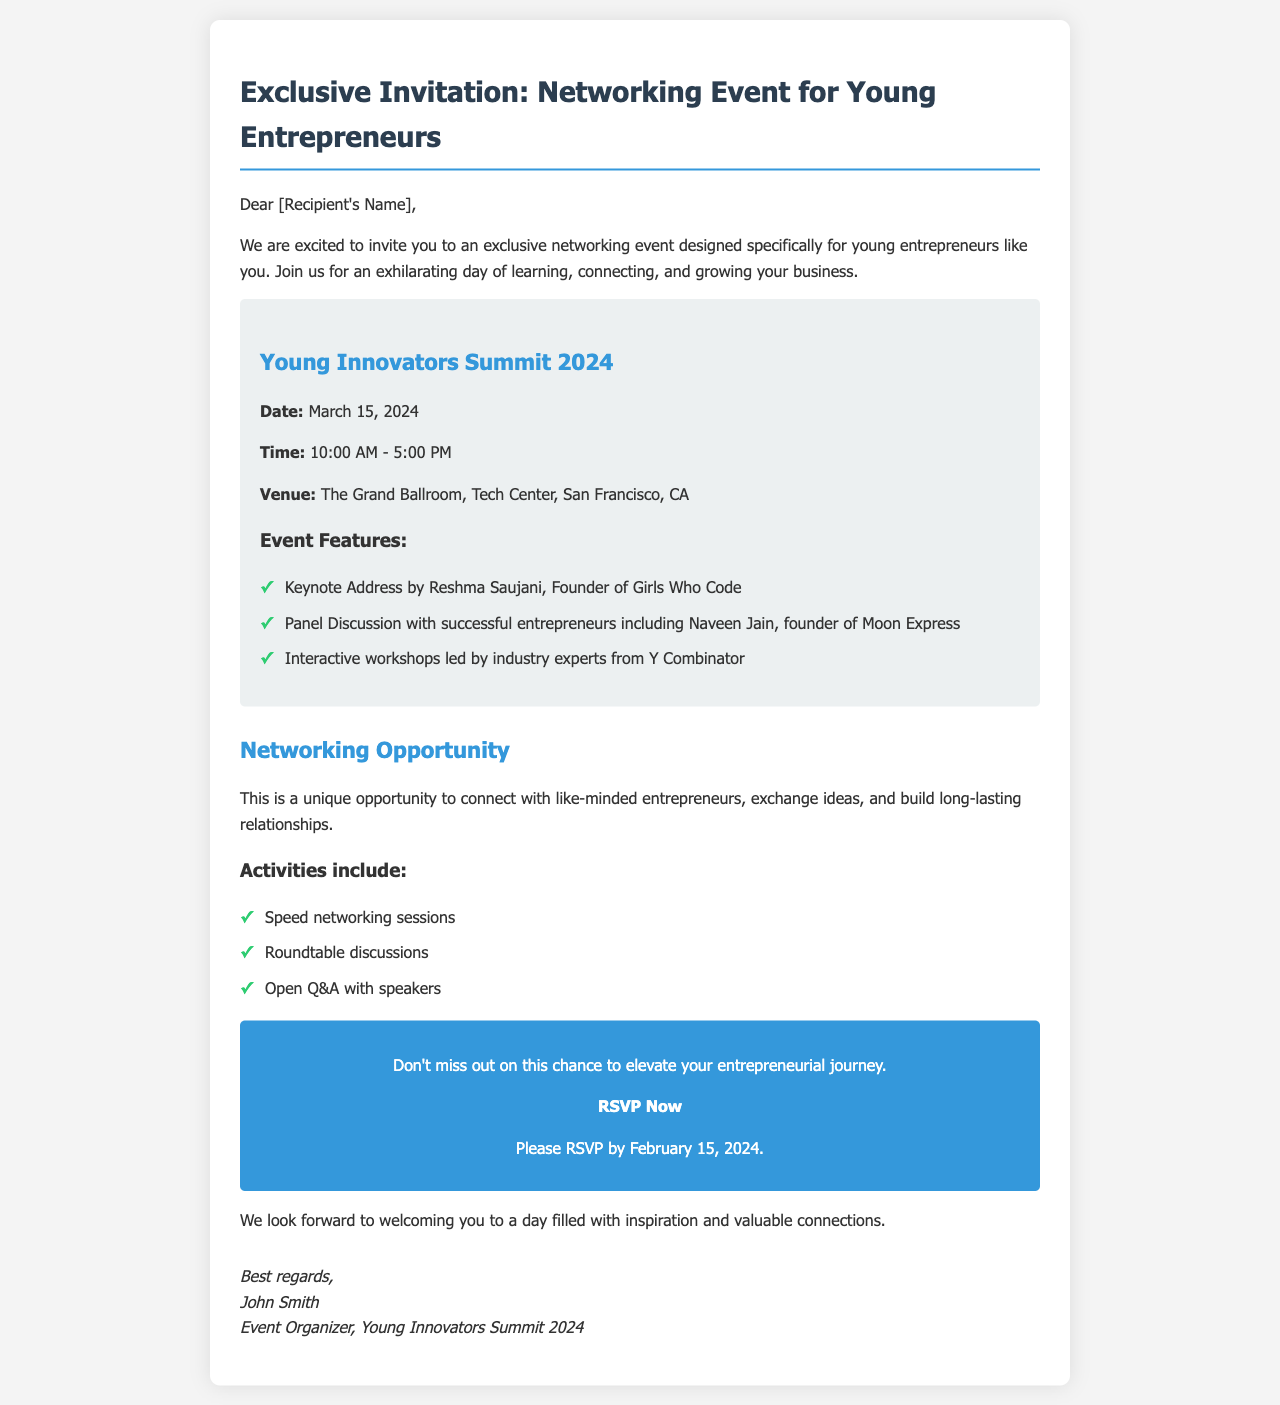What is the name of the event? The name of the event is mentioned in the title section of the document.
Answer: Young Innovators Summit 2024 What is the date of the event? The document gives a specific date for the event in the event details section.
Answer: March 15, 2024 Who is the keynote speaker? The document lists the keynote speaker in the event features section.
Answer: Reshma Saujani What time does the event start? The start time for the event is provided in the event details section.
Answer: 10:00 AM What is the venue of the event? The venue is specifically stated in the event details section of the document.
Answer: The Grand Ballroom, Tech Center, San Francisco, CA Who is organizing the event? The organizer of the event is mentioned in the closing signature of the document.
Answer: John Smith What activities are included in the event? The document lists activities that will take place during the event in the activities section.
Answer: Speed networking sessions When is the RSVP deadline? The RSVP deadline is explicitly mentioned towards the end of the document.
Answer: February 15, 2024 How long will the event last? The duration of the event can be deduced from the start and end times mentioned in the document.
Answer: 7 hours 